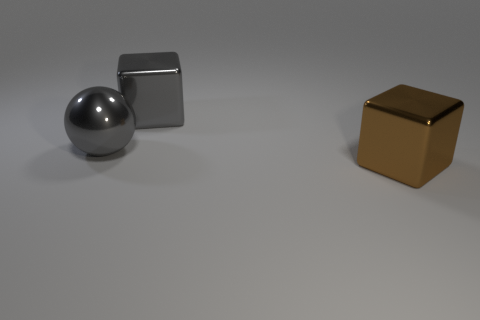Add 2 gray metallic things. How many objects exist? 5 Subtract all cubes. How many objects are left? 1 Subtract all shiny objects. Subtract all big red matte cubes. How many objects are left? 0 Add 2 brown metallic cubes. How many brown metallic cubes are left? 3 Add 1 gray cubes. How many gray cubes exist? 2 Subtract 0 purple spheres. How many objects are left? 3 